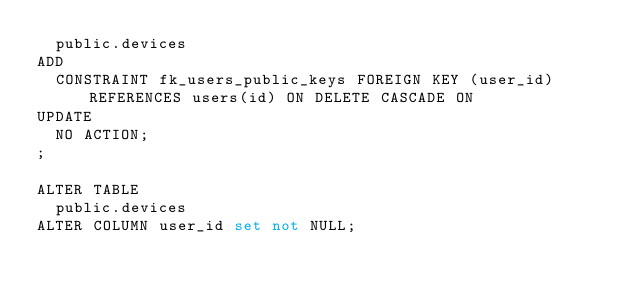Convert code to text. <code><loc_0><loc_0><loc_500><loc_500><_SQL_>  public.devices
ADD
  CONSTRAINT fk_users_public_keys FOREIGN KEY (user_id) REFERENCES users(id) ON DELETE CASCADE ON
UPDATE
  NO ACTION;
;

ALTER TABLE
  public.devices
ALTER COLUMN user_id set not NULL;
</code> 